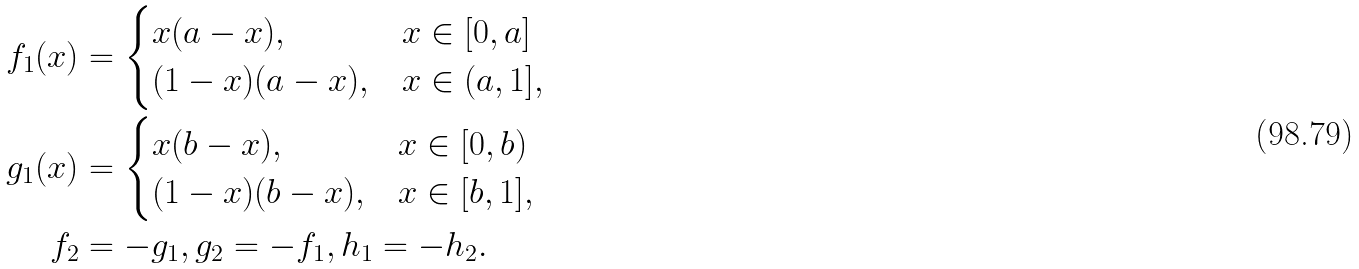<formula> <loc_0><loc_0><loc_500><loc_500>f _ { 1 } ( x ) & = \begin{cases} x ( a - x ) , & x \in [ 0 , a ] \\ ( 1 - x ) ( a - x ) , & x \in ( a , 1 ] , \end{cases} \\ g _ { 1 } ( x ) & = \begin{cases} x ( b - x ) , & x \in [ 0 , b ) \\ ( 1 - x ) ( b - x ) , & x \in [ b , 1 ] , \end{cases} \\ f _ { 2 } & = - g _ { 1 } , g _ { 2 } = - f _ { 1 } , h _ { 1 } = - h _ { 2 } .</formula> 